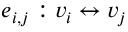Convert formula to latex. <formula><loc_0><loc_0><loc_500><loc_500>e _ { i , j } \colon v _ { i } \leftrightarrow v _ { j }</formula> 